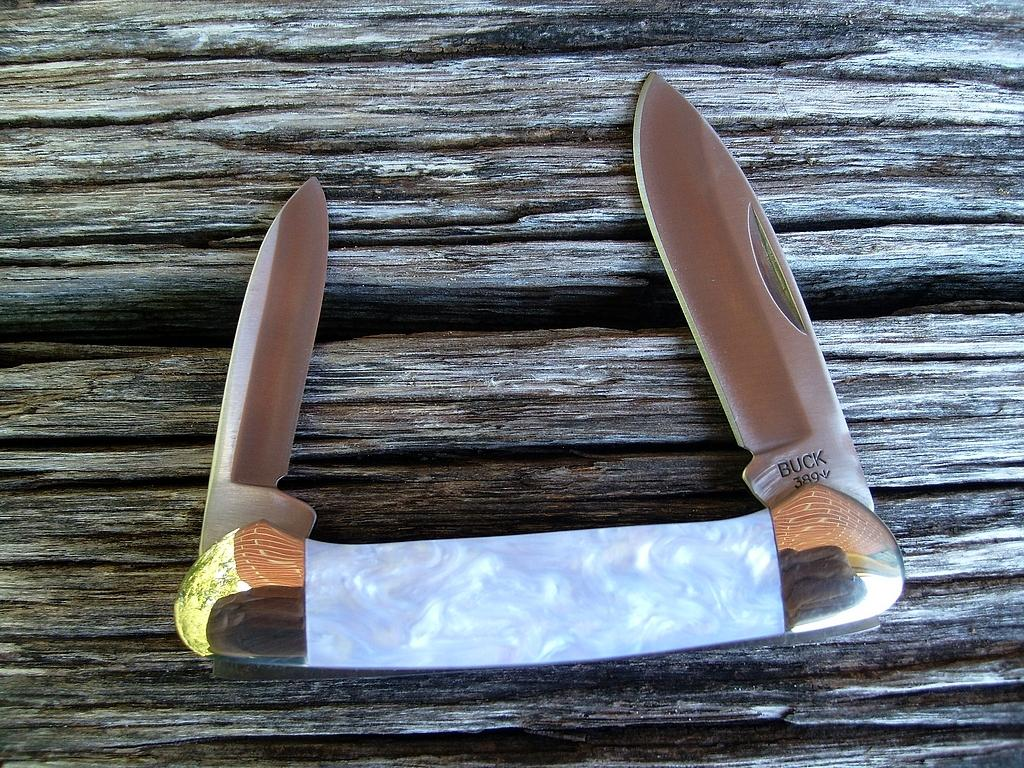What objects are present in the image? There are knives in the image. What type of surface are the knives placed on? The knives are on a wooden surface. What type of thread is being used to create a pattern on the knives? There is no thread present on the knives in the image. 